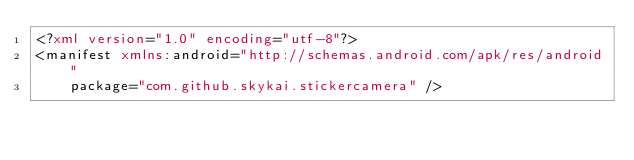Convert code to text. <code><loc_0><loc_0><loc_500><loc_500><_XML_><?xml version="1.0" encoding="utf-8"?>
<manifest xmlns:android="http://schemas.android.com/apk/res/android"
    package="com.github.skykai.stickercamera" />
</code> 